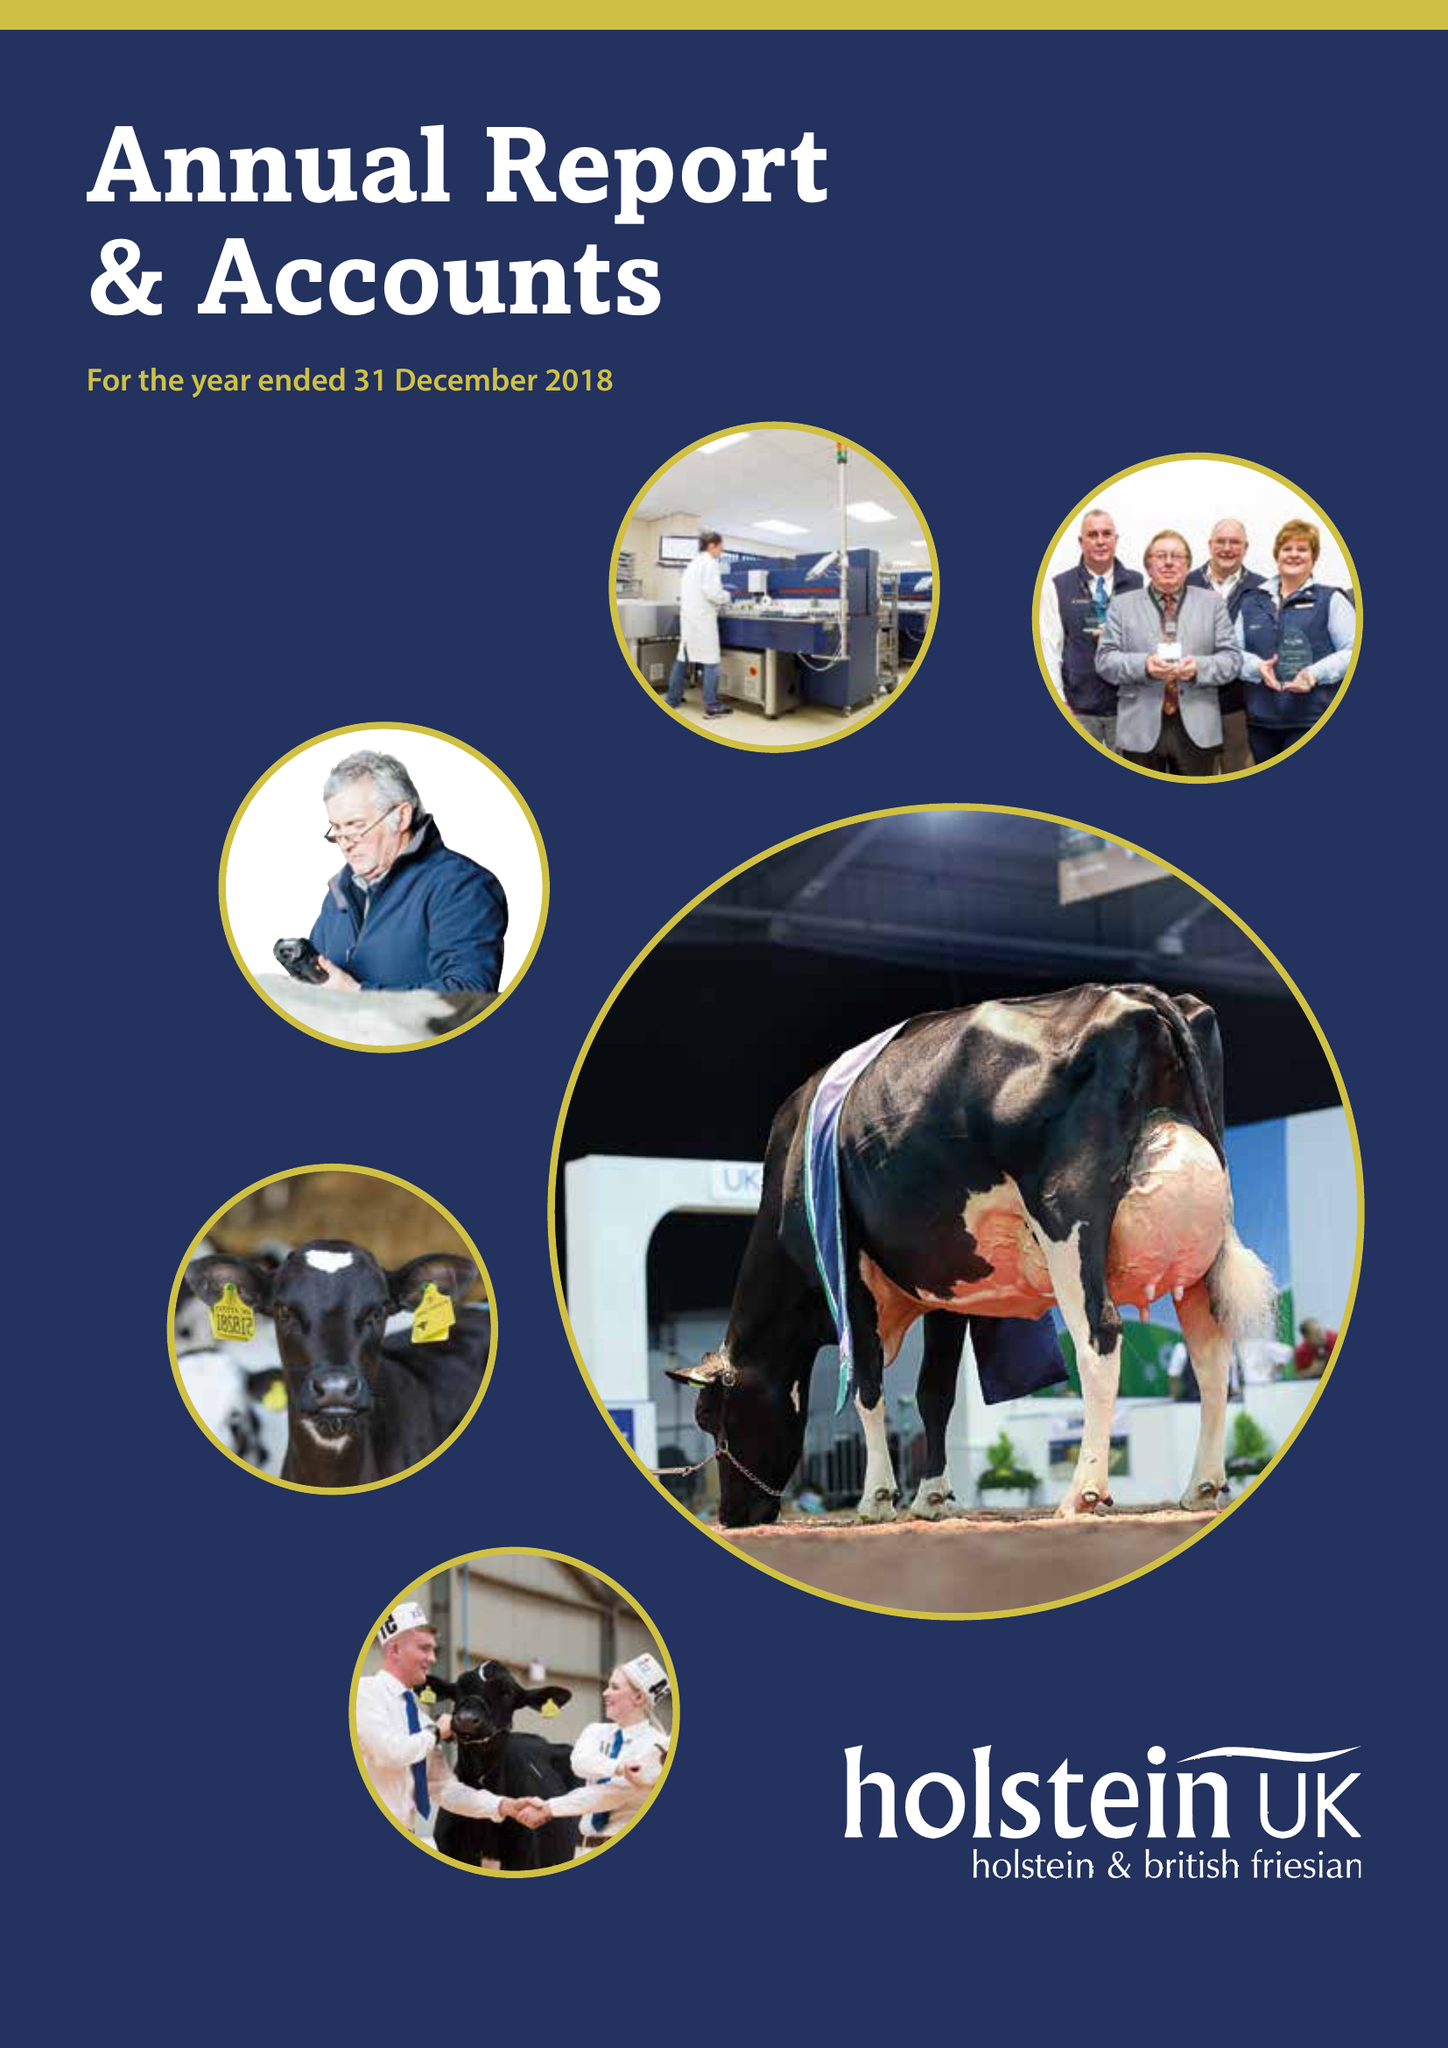What is the value for the income_annually_in_british_pounds?
Answer the question using a single word or phrase. 10980075.00 